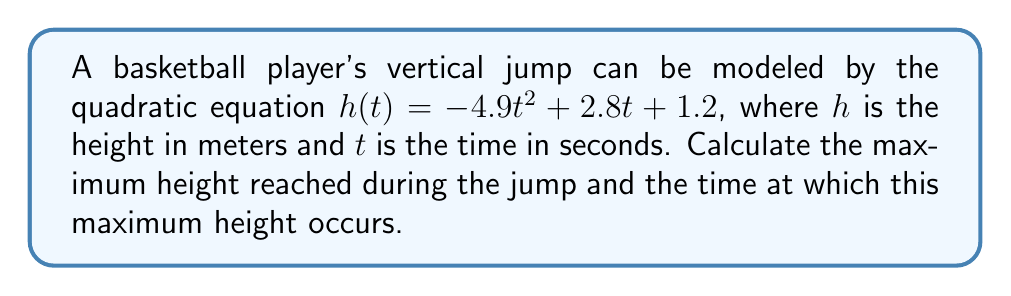Could you help me with this problem? To find the maximum height and the time at which it occurs, we need to follow these steps:

1) The quadratic equation is in the form $h(t) = at^2 + bt + c$, where:
   $a = -4.9$
   $b = 2.8$
   $c = 1.2$

2) For a quadratic function, the vertex represents the maximum (if $a < 0$) or minimum (if $a > 0$) point. In this case, $a < 0$, so the vertex will give us the maximum height.

3) The formula for the t-coordinate of the vertex is:
   $t = -\frac{b}{2a}$

4) Substituting our values:
   $t = -\frac{2.8}{2(-4.9)} = \frac{2.8}{9.8} \approx 0.2857$ seconds

5) To find the maximum height, we substitute this t-value back into our original equation:

   $h(0.2857) = -4.9(0.2857)^2 + 2.8(0.2857) + 1.2$
               $\approx -0.4 + 0.8 + 1.2$
               $\approx 1.6$ meters

Therefore, the maximum height is approximately 1.6 meters, reached at approximately 0.2857 seconds.
Answer: Maximum height: 1.6 m; Time: 0.2857 s 